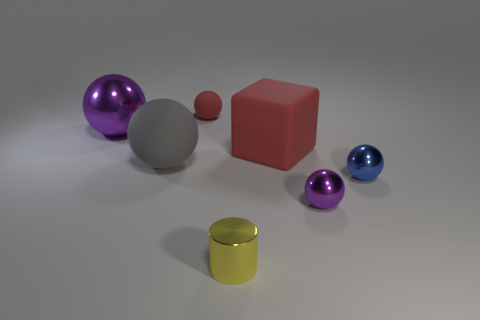Subtract all gray balls. How many balls are left? 4 Subtract all blue balls. How many balls are left? 4 Subtract all brown spheres. Subtract all purple cubes. How many spheres are left? 5 Add 3 yellow things. How many objects exist? 10 Subtract all balls. How many objects are left? 2 Add 7 cyan matte cylinders. How many cyan matte cylinders exist? 7 Subtract 0 green cylinders. How many objects are left? 7 Subtract all red balls. Subtract all gray matte spheres. How many objects are left? 5 Add 5 small red matte things. How many small red matte things are left? 6 